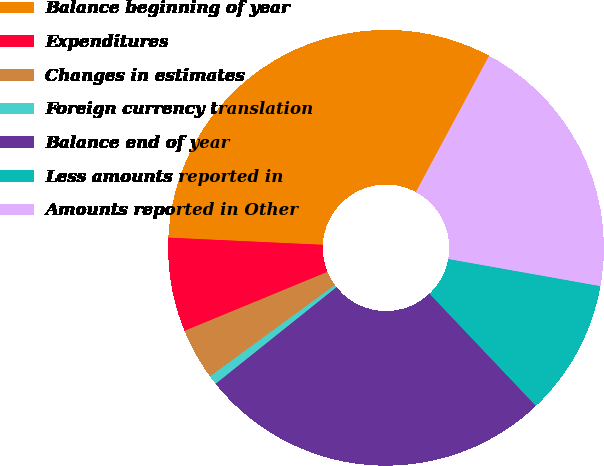Convert chart. <chart><loc_0><loc_0><loc_500><loc_500><pie_chart><fcel>Balance beginning of year<fcel>Expenditures<fcel>Changes in estimates<fcel>Foreign currency translation<fcel>Balance end of year<fcel>Less amounts reported in<fcel>Amounts reported in Other<nl><fcel>32.11%<fcel>6.97%<fcel>3.82%<fcel>0.68%<fcel>26.35%<fcel>10.11%<fcel>19.96%<nl></chart> 